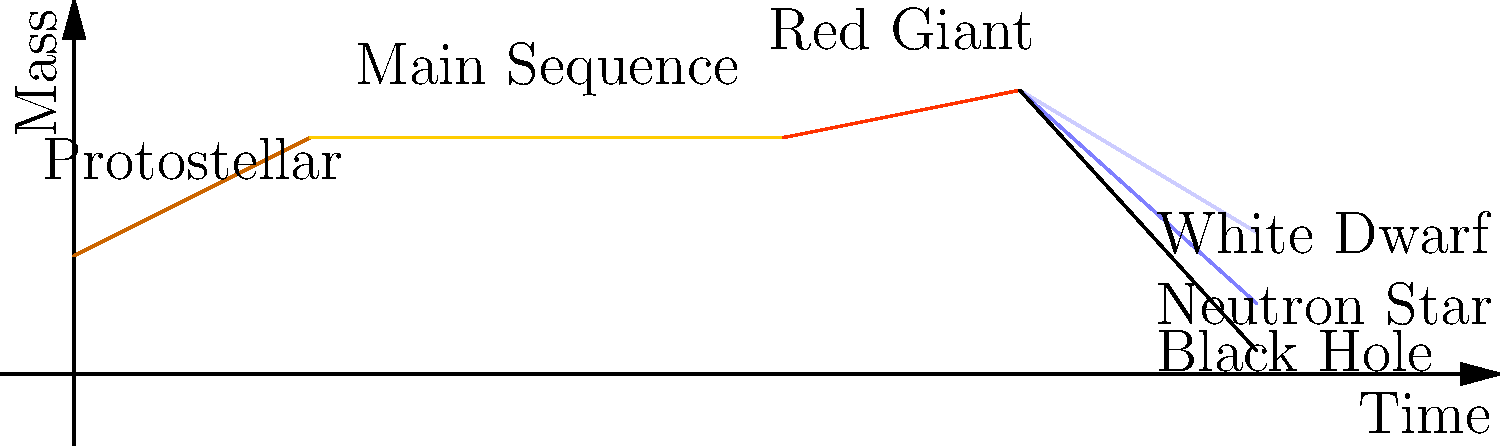In the context of international patent law for astronomical technologies, consider the life cycle of a star as depicted in the graph. Which end state would a star with an initial mass of approximately 20 solar masses ($20M_{\odot}$) most likely reach, and how might this knowledge impact the development of next-generation telescopes? To answer this question, we need to consider the life cycle of stars and how their initial mass affects their eventual fate:

1. Protostellar phase: All stars begin as collapsing clouds of gas and dust.

2. Main Sequence: Stars spend most of their lives in this phase, fusing hydrogen into helium in their cores.

3. Red Giant: As the hydrogen fuel is depleted, the star expands and cools, becoming a red giant.

4. End states: The final fate of a star depends on its initial mass:
   a. Stars with mass $< 8M_{\odot}$: become white dwarfs
   b. Stars with mass $8M_{\odot} - 20M_{\odot}$: become neutron stars
   c. Stars with mass $> 20M_{\odot}$: become black holes

Given that the star in question has an initial mass of $20M_{\odot}$, it falls at the upper end of the range for neutron star formation. However, considering mass loss during the star's lifetime, it's more likely to end up as a neutron star rather than a black hole.

This knowledge impacts next-generation telescope development in several ways:
1. Gravitational wave detection: Neutron stars in binary systems are prime targets for gravitational wave astronomy.
2. Extreme physics: Neutron stars allow us to study matter under extreme conditions, informing both astrophysics and nuclear physics.
3. Pulsar timing: Highly precise neutron star (pulsar) observations can be used for navigation and timekeeping in space.

From a patent law perspective, innovations in these areas could lead to new technologies with potential commercial applications, such as improved timekeeping devices or novel materials inspired by neutron star physics.
Answer: Neutron star; informs gravitational wave detection, extreme physics study, and pulsar timing technologies. 